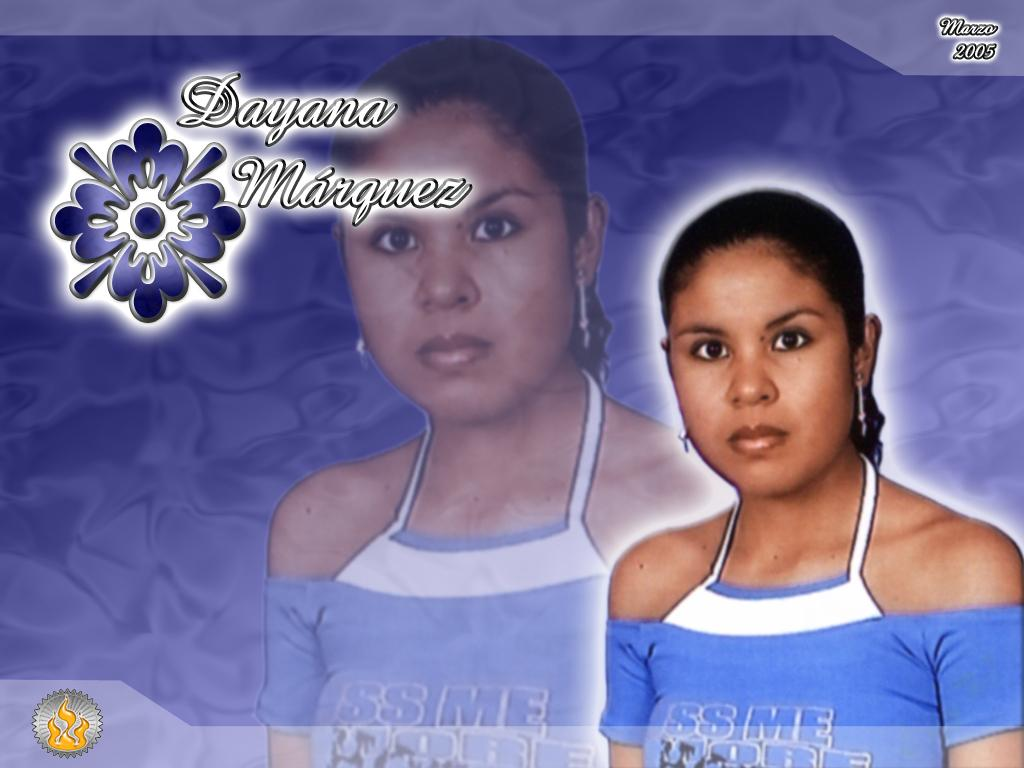Provide a one-sentence caption for the provided image. A picture of a woman named Dayana Marquez. 